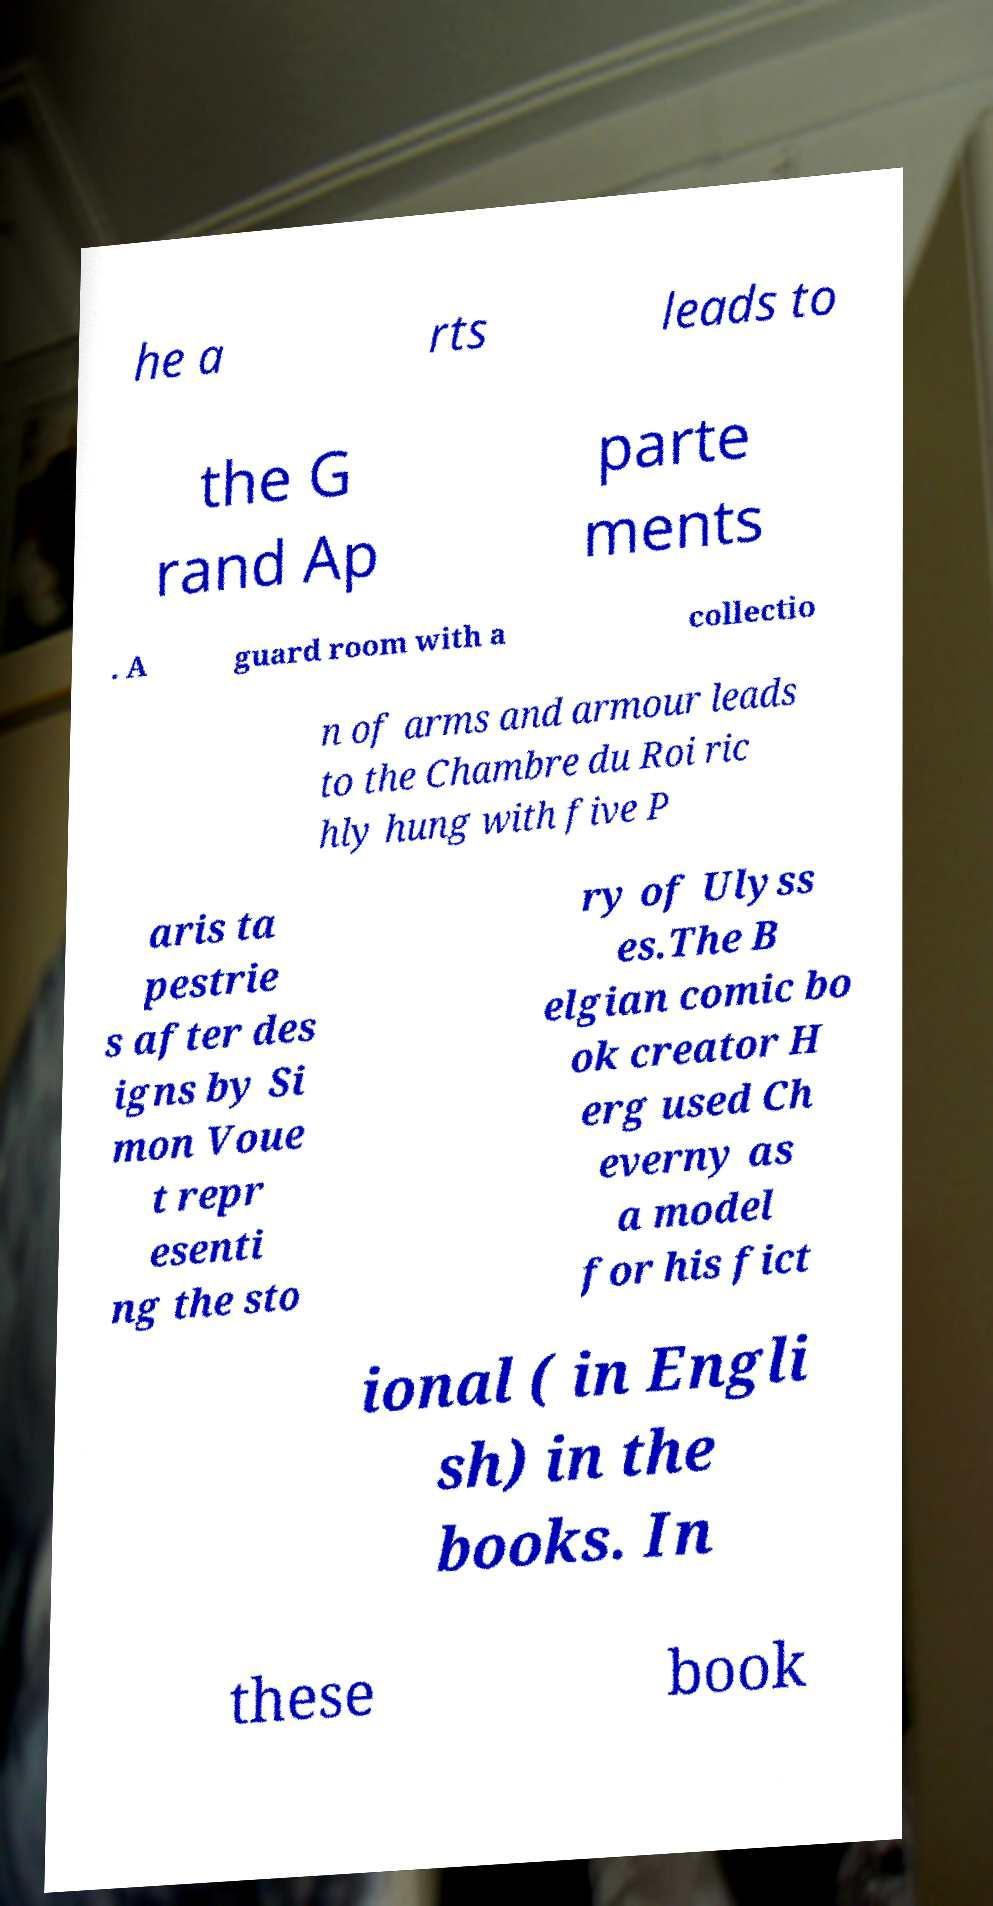Can you read and provide the text displayed in the image?This photo seems to have some interesting text. Can you extract and type it out for me? he a rts leads to the G rand Ap parte ments . A guard room with a collectio n of arms and armour leads to the Chambre du Roi ric hly hung with five P aris ta pestrie s after des igns by Si mon Voue t repr esenti ng the sto ry of Ulyss es.The B elgian comic bo ok creator H erg used Ch everny as a model for his fict ional ( in Engli sh) in the books. In these book 